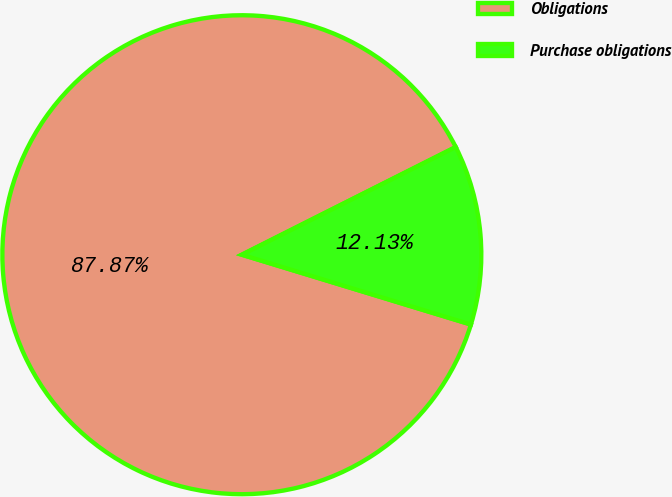Convert chart. <chart><loc_0><loc_0><loc_500><loc_500><pie_chart><fcel>Obligations<fcel>Purchase obligations<nl><fcel>87.87%<fcel>12.13%<nl></chart> 